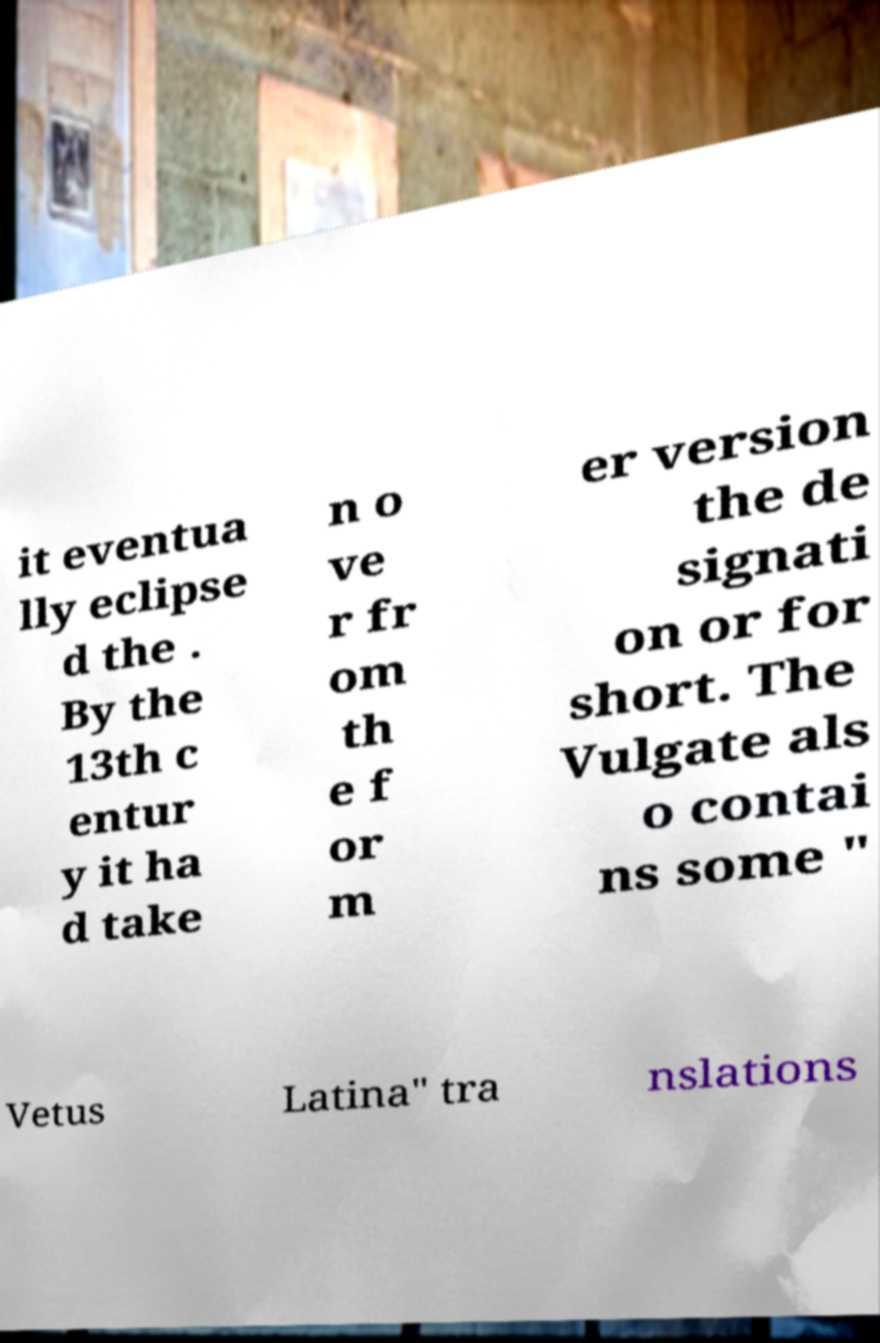There's text embedded in this image that I need extracted. Can you transcribe it verbatim? it eventua lly eclipse d the . By the 13th c entur y it ha d take n o ve r fr om th e f or m er version the de signati on or for short. The Vulgate als o contai ns some " Vetus Latina" tra nslations 